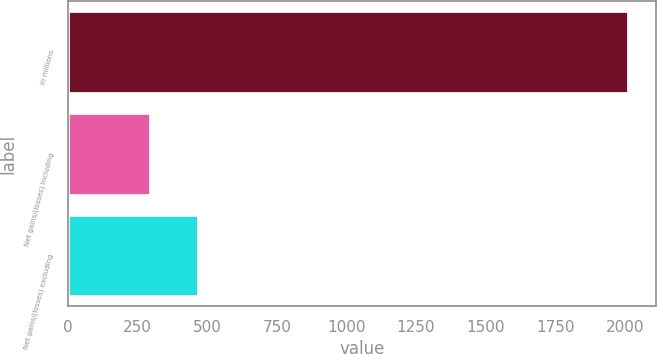<chart> <loc_0><loc_0><loc_500><loc_500><bar_chart><fcel>in millions<fcel>Net gains/(losses) including<fcel>Net gains/(losses) excluding<nl><fcel>2013<fcel>296<fcel>467.7<nl></chart> 